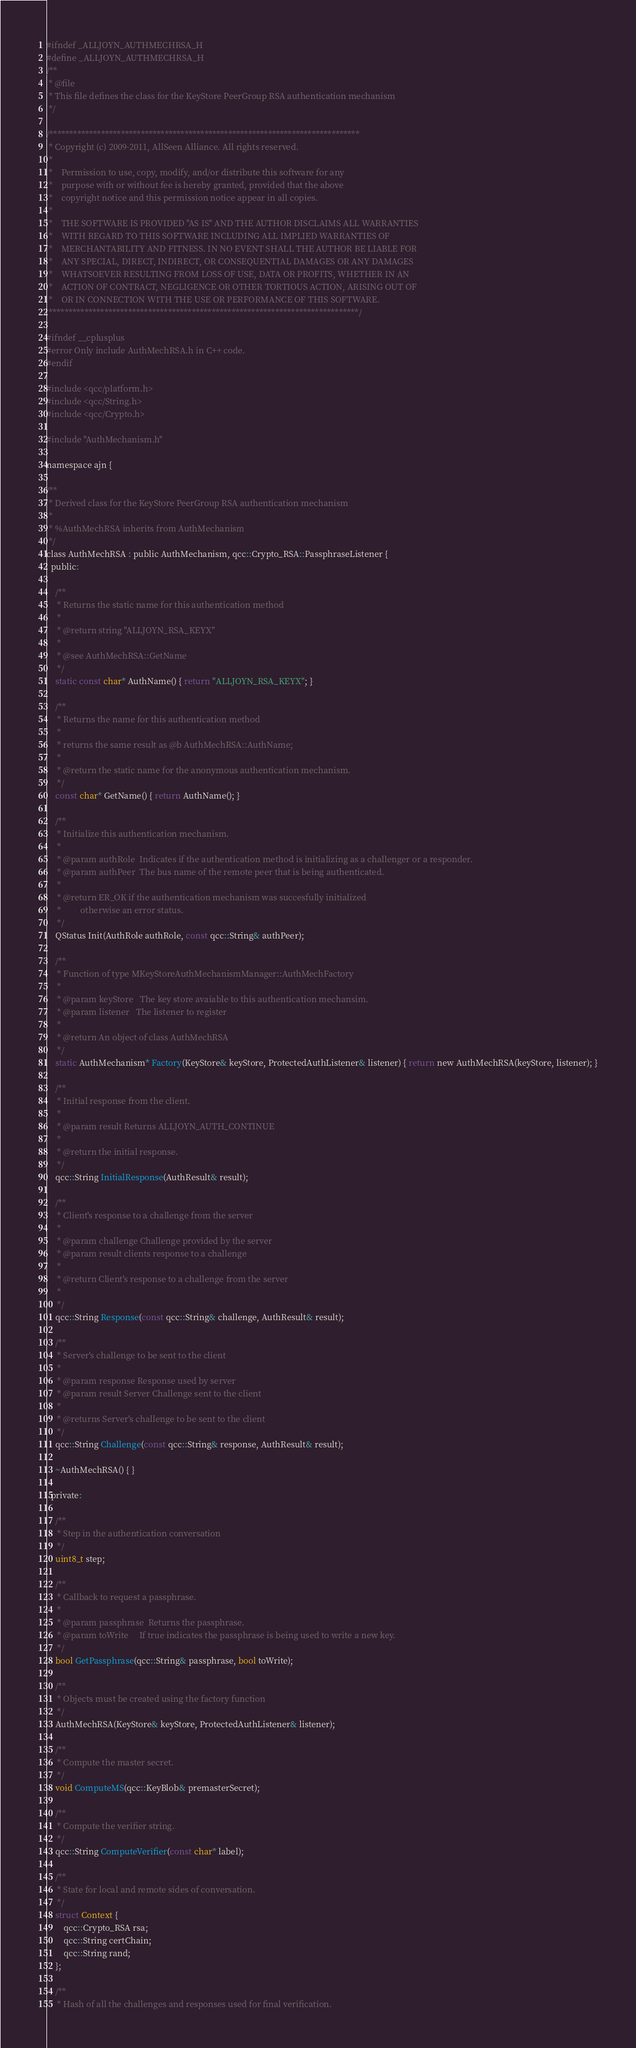<code> <loc_0><loc_0><loc_500><loc_500><_C_>#ifndef _ALLJOYN_AUTHMECHRSA_H
#define _ALLJOYN_AUTHMECHRSA_H
/**
 * @file
 * This file defines the class for the KeyStore PeerGroup RSA authentication mechanism
 */

/******************************************************************************
 * Copyright (c) 2009-2011, AllSeen Alliance. All rights reserved.
 *
 *    Permission to use, copy, modify, and/or distribute this software for any
 *    purpose with or without fee is hereby granted, provided that the above
 *    copyright notice and this permission notice appear in all copies.
 *
 *    THE SOFTWARE IS PROVIDED "AS IS" AND THE AUTHOR DISCLAIMS ALL WARRANTIES
 *    WITH REGARD TO THIS SOFTWARE INCLUDING ALL IMPLIED WARRANTIES OF
 *    MERCHANTABILITY AND FITNESS. IN NO EVENT SHALL THE AUTHOR BE LIABLE FOR
 *    ANY SPECIAL, DIRECT, INDIRECT, OR CONSEQUENTIAL DAMAGES OR ANY DAMAGES
 *    WHATSOEVER RESULTING FROM LOSS OF USE, DATA OR PROFITS, WHETHER IN AN
 *    ACTION OF CONTRACT, NEGLIGENCE OR OTHER TORTIOUS ACTION, ARISING OUT OF
 *    OR IN CONNECTION WITH THE USE OR PERFORMANCE OF THIS SOFTWARE.
 ******************************************************************************/

#ifndef __cplusplus
#error Only include AuthMechRSA.h in C++ code.
#endif

#include <qcc/platform.h>
#include <qcc/String.h>
#include <qcc/Crypto.h>

#include "AuthMechanism.h"

namespace ajn {

/**
 * Derived class for the KeyStore PeerGroup RSA authentication mechanism
 *
 * %AuthMechRSA inherits from AuthMechanism
 */
class AuthMechRSA : public AuthMechanism, qcc::Crypto_RSA::PassphraseListener {
  public:

    /**
     * Returns the static name for this authentication method
     *
     * @return string "ALLJOYN_RSA_KEYX"
     *
     * @see AuthMechRSA::GetName
     */
    static const char* AuthName() { return "ALLJOYN_RSA_KEYX"; }

    /**
     * Returns the name for this authentication method
     *
     * returns the same result as @b AuthMechRSA::AuthName;
     *
     * @return the static name for the anonymous authentication mechanism.
     */
    const char* GetName() { return AuthName(); }

    /**
     * Initialize this authentication mechanism.
     *
     * @param authRole  Indicates if the authentication method is initializing as a challenger or a responder.
     * @param authPeer  The bus name of the remote peer that is being authenticated.
     *
     * @return ER_OK if the authentication mechanism was succesfully initialized
     *         otherwise an error status.
     */
    QStatus Init(AuthRole authRole, const qcc::String& authPeer);

    /**
     * Function of type MKeyStoreAuthMechanismManager::AuthMechFactory
     *
     * @param keyStore   The key store avaiable to this authentication mechansim.
     * @param listener   The listener to register
     *
     * @return An object of class AuthMechRSA
     */
    static AuthMechanism* Factory(KeyStore& keyStore, ProtectedAuthListener& listener) { return new AuthMechRSA(keyStore, listener); }

    /**
     * Initial response from the client.
     *
     * @param result Returns ALLJOYN_AUTH_CONTINUE
     *
     * @return the initial response.
     */
    qcc::String InitialResponse(AuthResult& result);

    /**
     * Client's response to a challenge from the server
     *
     * @param challenge Challenge provided by the server
     * @param result clients response to a challenge
     *
     * @return Client's response to a challenge from the server
     *
     */
    qcc::String Response(const qcc::String& challenge, AuthResult& result);

    /**
     * Server's challenge to be sent to the client
     *
     * @param response Response used by server
     * @param result Server Challenge sent to the client
     *
     * @returns Server's challenge to be sent to the client
     */
    qcc::String Challenge(const qcc::String& response, AuthResult& result);

    ~AuthMechRSA() { }

  private:

    /**
     * Step in the authentication conversation
     */
    uint8_t step;

    /**
     * Callback to request a passphrase.
     *
     * @param passphrase  Returns the passphrase.
     * @param toWrite     If true indicates the passphrase is being used to write a new key.
     */
    bool GetPassphrase(qcc::String& passphrase, bool toWrite);

    /**
     * Objects must be created using the factory function
     */
    AuthMechRSA(KeyStore& keyStore, ProtectedAuthListener& listener);

    /**
     * Compute the master secret.
     */
    void ComputeMS(qcc::KeyBlob& premasterSecret);

    /**
     * Compute the verifier string.
     */
    qcc::String ComputeVerifier(const char* label);

    /**
     * State for local and remote sides of conversation.
     */
    struct Context {
        qcc::Crypto_RSA rsa;
        qcc::String certChain;
        qcc::String rand;
    };

    /**
     * Hash of all the challenges and responses used for final verification.</code> 